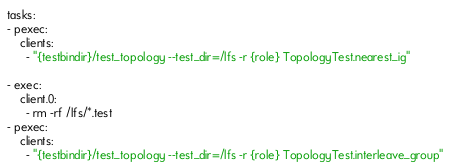<code> <loc_0><loc_0><loc_500><loc_500><_YAML_>tasks:
- pexec:
    clients:
      - "{testbindir}/test_topology --test_dir=/lfs -r {role} TopologyTest.nearest_ig"

- exec:
    client.0:
      - rm -rf /lfs/*.test
- pexec:
    clients:
      - "{testbindir}/test_topology --test_dir=/lfs -r {role} TopologyTest.interleave_group"
</code> 